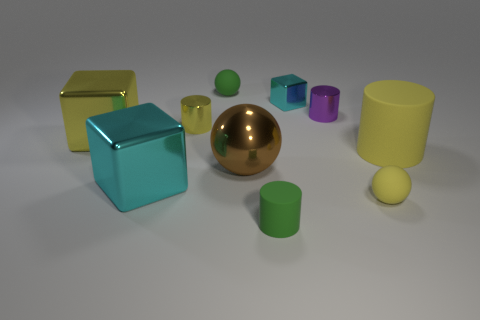How many yellow matte objects are the same size as the yellow metal cylinder?
Your response must be concise. 1. Is the number of yellow things that are left of the purple cylinder less than the number of big blue matte spheres?
Provide a succinct answer. No. How big is the metallic cylinder to the right of the tiny ball that is behind the big brown shiny ball?
Give a very brief answer. Small. How many objects are either large yellow rubber spheres or yellow balls?
Offer a terse response. 1. Are there any other shiny cylinders of the same color as the big cylinder?
Your response must be concise. Yes. Are there fewer big yellow cubes than yellow matte things?
Make the answer very short. Yes. How many things are cyan rubber cylinders or tiny yellow rubber balls in front of the small metallic cube?
Provide a short and direct response. 1. Is there a cylinder that has the same material as the big cyan object?
Ensure brevity in your answer.  Yes. There is a yellow block that is the same size as the metallic ball; what is it made of?
Provide a succinct answer. Metal. What is the material of the large yellow thing that is to the right of the tiny metal cylinder that is left of the big brown shiny ball?
Ensure brevity in your answer.  Rubber. 